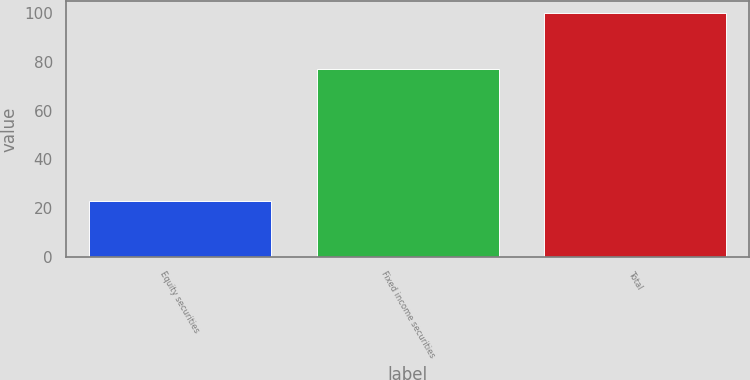<chart> <loc_0><loc_0><loc_500><loc_500><bar_chart><fcel>Equity securities<fcel>Fixed income securities<fcel>Total<nl><fcel>23<fcel>77<fcel>100<nl></chart> 